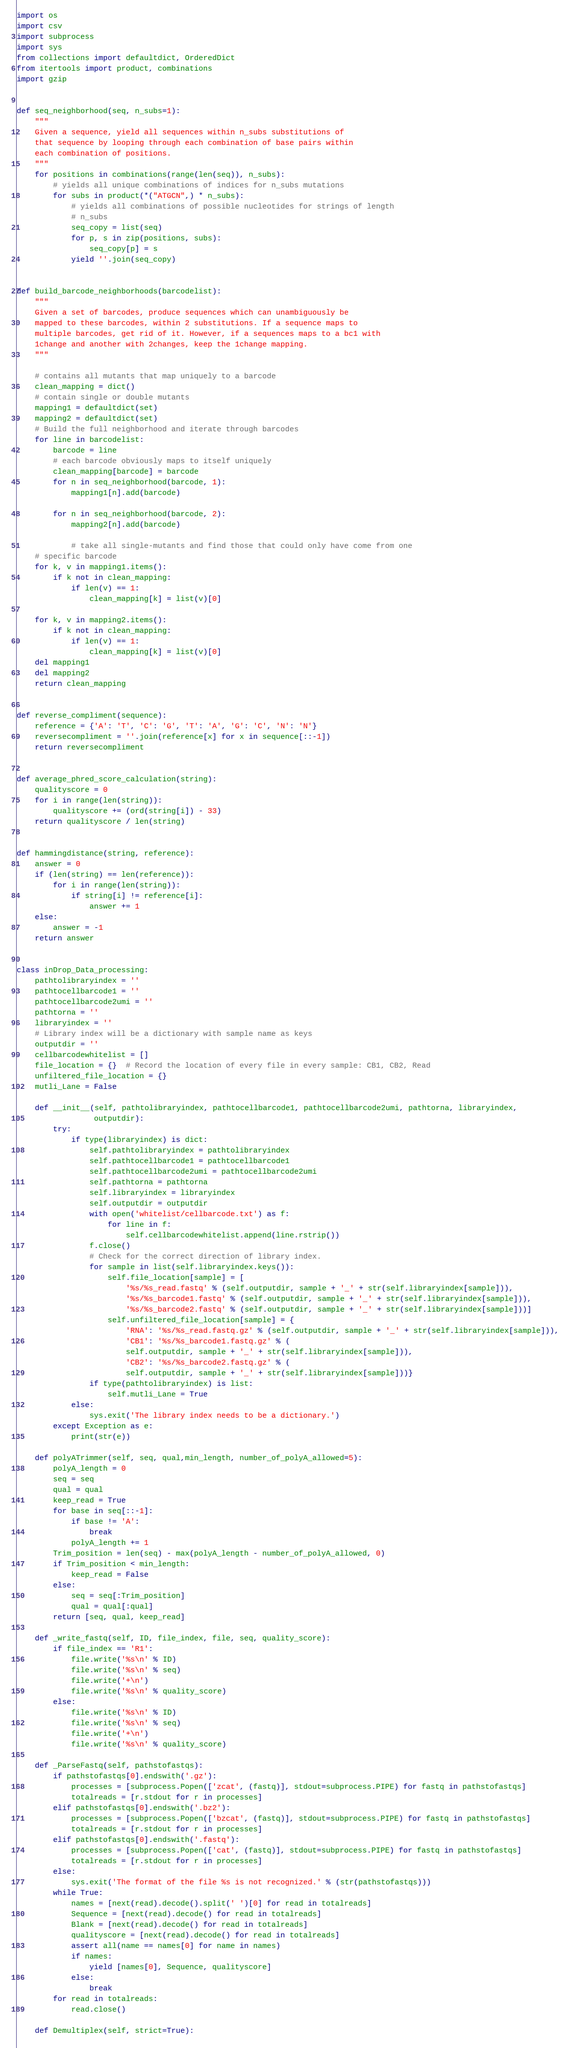<code> <loc_0><loc_0><loc_500><loc_500><_Python_>import os
import csv
import subprocess
import sys
from collections import defaultdict, OrderedDict
from itertools import product, combinations
import gzip


def seq_neighborhood(seq, n_subs=1):
    """
    Given a sequence, yield all sequences within n_subs substitutions of
    that sequence by looping through each combination of base pairs within
    each combination of positions.
    """
    for positions in combinations(range(len(seq)), n_subs):
        # yields all unique combinations of indices for n_subs mutations
        for subs in product(*("ATGCN",) * n_subs):
            # yields all combinations of possible nucleotides for strings of length
            # n_subs
            seq_copy = list(seq)
            for p, s in zip(positions, subs):
                seq_copy[p] = s
            yield ''.join(seq_copy)


def build_barcode_neighborhoods(barcodelist):
    """
    Given a set of barcodes, produce sequences which can unambiguously be
    mapped to these barcodes, within 2 substitutions. If a sequence maps to
    multiple barcodes, get rid of it. However, if a sequences maps to a bc1 with
    1change and another with 2changes, keep the 1change mapping.
    """

    # contains all mutants that map uniquely to a barcode
    clean_mapping = dict()
    # contain single or double mutants
    mapping1 = defaultdict(set)
    mapping2 = defaultdict(set)
    # Build the full neighborhood and iterate through barcodes
    for line in barcodelist:
        barcode = line
        # each barcode obviously maps to itself uniquely
        clean_mapping[barcode] = barcode
        for n in seq_neighborhood(barcode, 1):
            mapping1[n].add(barcode)

        for n in seq_neighborhood(barcode, 2):
            mapping2[n].add(barcode)

            # take all single-mutants and find those that could only have come from one
    # specific barcode
    for k, v in mapping1.items():
        if k not in clean_mapping:
            if len(v) == 1:
                clean_mapping[k] = list(v)[0]

    for k, v in mapping2.items():
        if k not in clean_mapping:
            if len(v) == 1:
                clean_mapping[k] = list(v)[0]
    del mapping1
    del mapping2
    return clean_mapping


def reverse_compliment(sequence):
    reference = {'A': 'T', 'C': 'G', 'T': 'A', 'G': 'C', 'N': 'N'}
    reversecompliment = ''.join(reference[x] for x in sequence[::-1])
    return reversecompliment


def average_phred_score_calculation(string):
    qualityscore = 0
    for i in range(len(string)):
        qualityscore += (ord(string[i]) - 33)
    return qualityscore / len(string)


def hammingdistance(string, reference):
    answer = 0
    if (len(string) == len(reference)):
        for i in range(len(string)):
            if string[i] != reference[i]:
                answer += 1
    else:
        answer = -1
    return answer


class inDrop_Data_processing:
    pathtolibraryindex = ''
    pathtocellbarcode1 = ''
    pathtocellbarcode2umi = ''
    pathtorna = ''
    libraryindex = ''
    # Library index will be a dictionary with sample name as keys
    outputdir = ''
    cellbarcodewhitelist = []
    file_location = {}  # Record the location of every file in every sample: CB1, CB2, Read
    unfiltered_file_location = {}
    mutli_Lane = False

    def __init__(self, pathtolibraryindex, pathtocellbarcode1, pathtocellbarcode2umi, pathtorna, libraryindex,
                 outputdir):
        try:
            if type(libraryindex) is dict:
                self.pathtolibraryindex = pathtolibraryindex
                self.pathtocellbarcode1 = pathtocellbarcode1
                self.pathtocellbarcode2umi = pathtocellbarcode2umi
                self.pathtorna = pathtorna
                self.libraryindex = libraryindex
                self.outputdir = outputdir
                with open('whitelist/cellbarcode.txt') as f:
                    for line in f:
                        self.cellbarcodewhitelist.append(line.rstrip())
                f.close()
                # Check for the correct direction of library index.
                for sample in list(self.libraryindex.keys()):
                    self.file_location[sample] = [
                        '%s/%s_read.fastq' % (self.outputdir, sample + '_' + str(self.libraryindex[sample])),
                        '%s/%s_barcode1.fastq' % (self.outputdir, sample + '_' + str(self.libraryindex[sample])),
                        '%s/%s_barcode2.fastq' % (self.outputdir, sample + '_' + str(self.libraryindex[sample]))]
                    self.unfiltered_file_location[sample] = {
                        'RNA': '%s/%s_read.fastq.gz' % (self.outputdir, sample + '_' + str(self.libraryindex[sample])),
                        'CB1': '%s/%s_barcode1.fastq.gz' % (
                        self.outputdir, sample + '_' + str(self.libraryindex[sample])),
                        'CB2': '%s/%s_barcode2.fastq.gz' % (
                        self.outputdir, sample + '_' + str(self.libraryindex[sample]))}
                if type(pathtolibraryindex) is list:
                    self.mutli_Lane = True
            else:
                sys.exit('The library index needs to be a dictionary.')
        except Exception as e:
            print(str(e))

    def polyATrimmer(self, seq, qual,min_length, number_of_polyA_allowed=5):
        polyA_length = 0
        seq = seq
        qual = qual
        keep_read = True
        for base in seq[::-1]:
            if base != 'A':
                break
            polyA_length += 1
        Trim_position = len(seq) - max(polyA_length - number_of_polyA_allowed, 0)
        if Trim_position < min_length:
            keep_read = False
        else:
            seq = seq[:Trim_position]
            qual = qual[:qual]
        return [seq, qual, keep_read]

    def _write_fastq(self, ID, file_index, file, seq, quality_score):
        if file_index == 'R1':
            file.write('%s\n' % ID)
            file.write('%s\n' % seq)
            file.write('+\n')
            file.write('%s\n' % quality_score)
        else:
            file.write('%s\n' % ID)
            file.write('%s\n' % seq)
            file.write('+\n')
            file.write('%s\n' % quality_score)

    def _ParseFastq(self, pathstofastqs):
        if pathstofastqs[0].endswith('.gz'):
            processes = [subprocess.Popen(['zcat', (fastq)], stdout=subprocess.PIPE) for fastq in pathstofastqs]
            totalreads = [r.stdout for r in processes]
        elif pathstofastqs[0].endswith('.bz2'):
            processes = [subprocess.Popen(['bzcat', (fastq)], stdout=subprocess.PIPE) for fastq in pathstofastqs]
            totalreads = [r.stdout for r in processes]
        elif pathstofastqs[0].endswith('.fastq'):
            processes = [subprocess.Popen(['cat', (fastq)], stdout=subprocess.PIPE) for fastq in pathstofastqs]
            totalreads = [r.stdout for r in processes]
        else:
            sys.exit('The format of the file %s is not recognized.' % (str(pathstofastqs)))
        while True:
            names = [next(read).decode().split(' ')[0] for read in totalreads]
            Sequence = [next(read).decode() for read in totalreads]
            Blank = [next(read).decode() for read in totalreads]
            qualityscore = [next(read).decode() for read in totalreads]
            assert all(name == names[0] for name in names)
            if names:
                yield [names[0], Sequence, qualityscore]
            else:
                break
        for read in totalreads:
            read.close()

    def Demultiplex(self, strict=True):</code> 